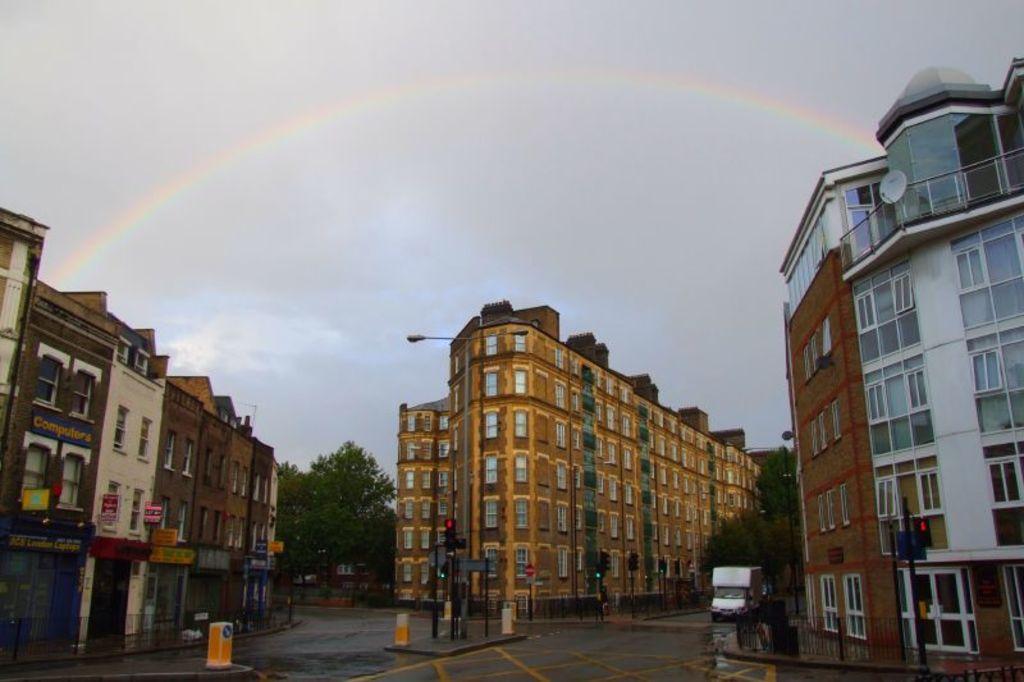How would you summarize this image in a sentence or two? This picture shows few buildings and few trees and we see a vehicle moving on the road and we see a pole light and couple of traffic signal lights and we see a cloudy sky and a rainbow. 